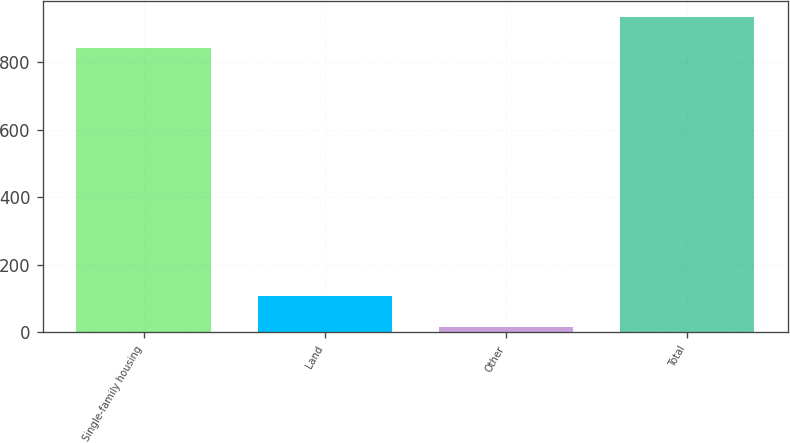<chart> <loc_0><loc_0><loc_500><loc_500><bar_chart><fcel>Single-family housing<fcel>Land<fcel>Other<fcel>Total<nl><fcel>842<fcel>107.6<fcel>17<fcel>932.6<nl></chart> 